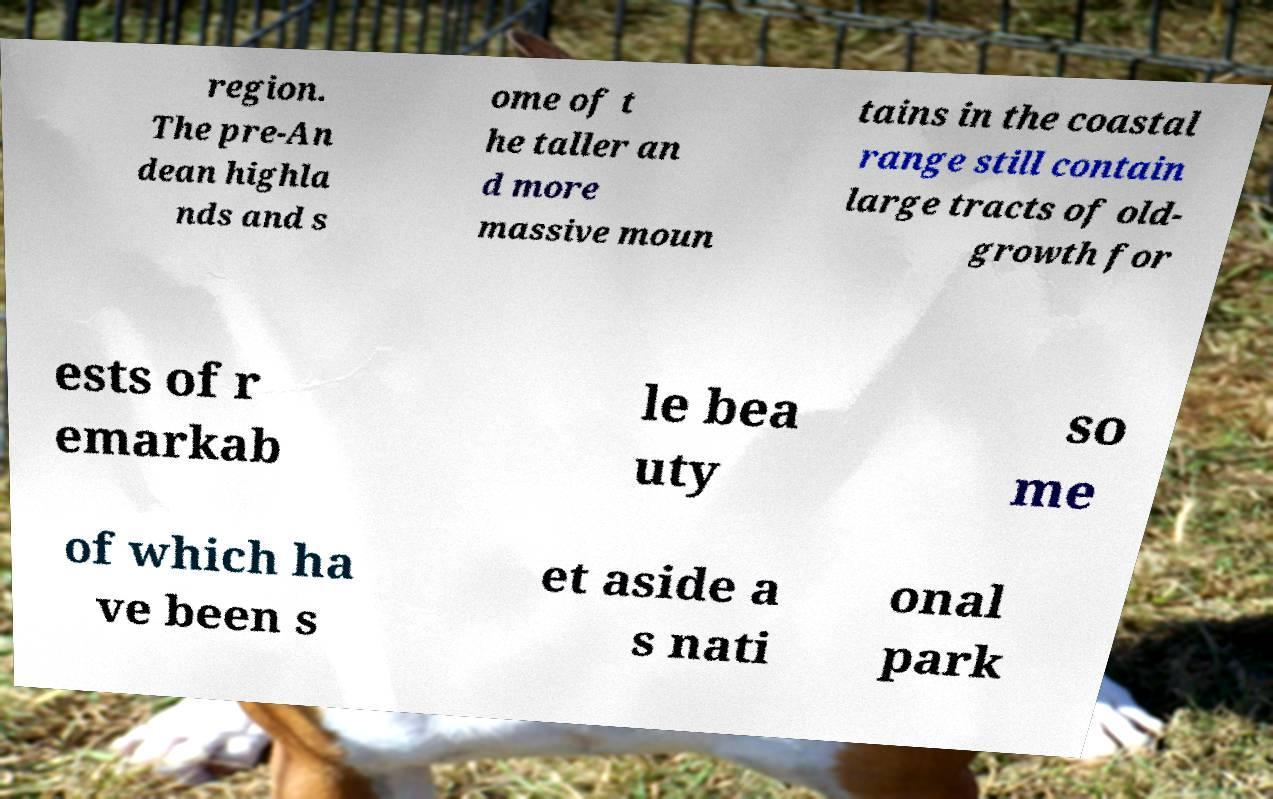Can you read and provide the text displayed in the image?This photo seems to have some interesting text. Can you extract and type it out for me? region. The pre-An dean highla nds and s ome of t he taller an d more massive moun tains in the coastal range still contain large tracts of old- growth for ests of r emarkab le bea uty so me of which ha ve been s et aside a s nati onal park 